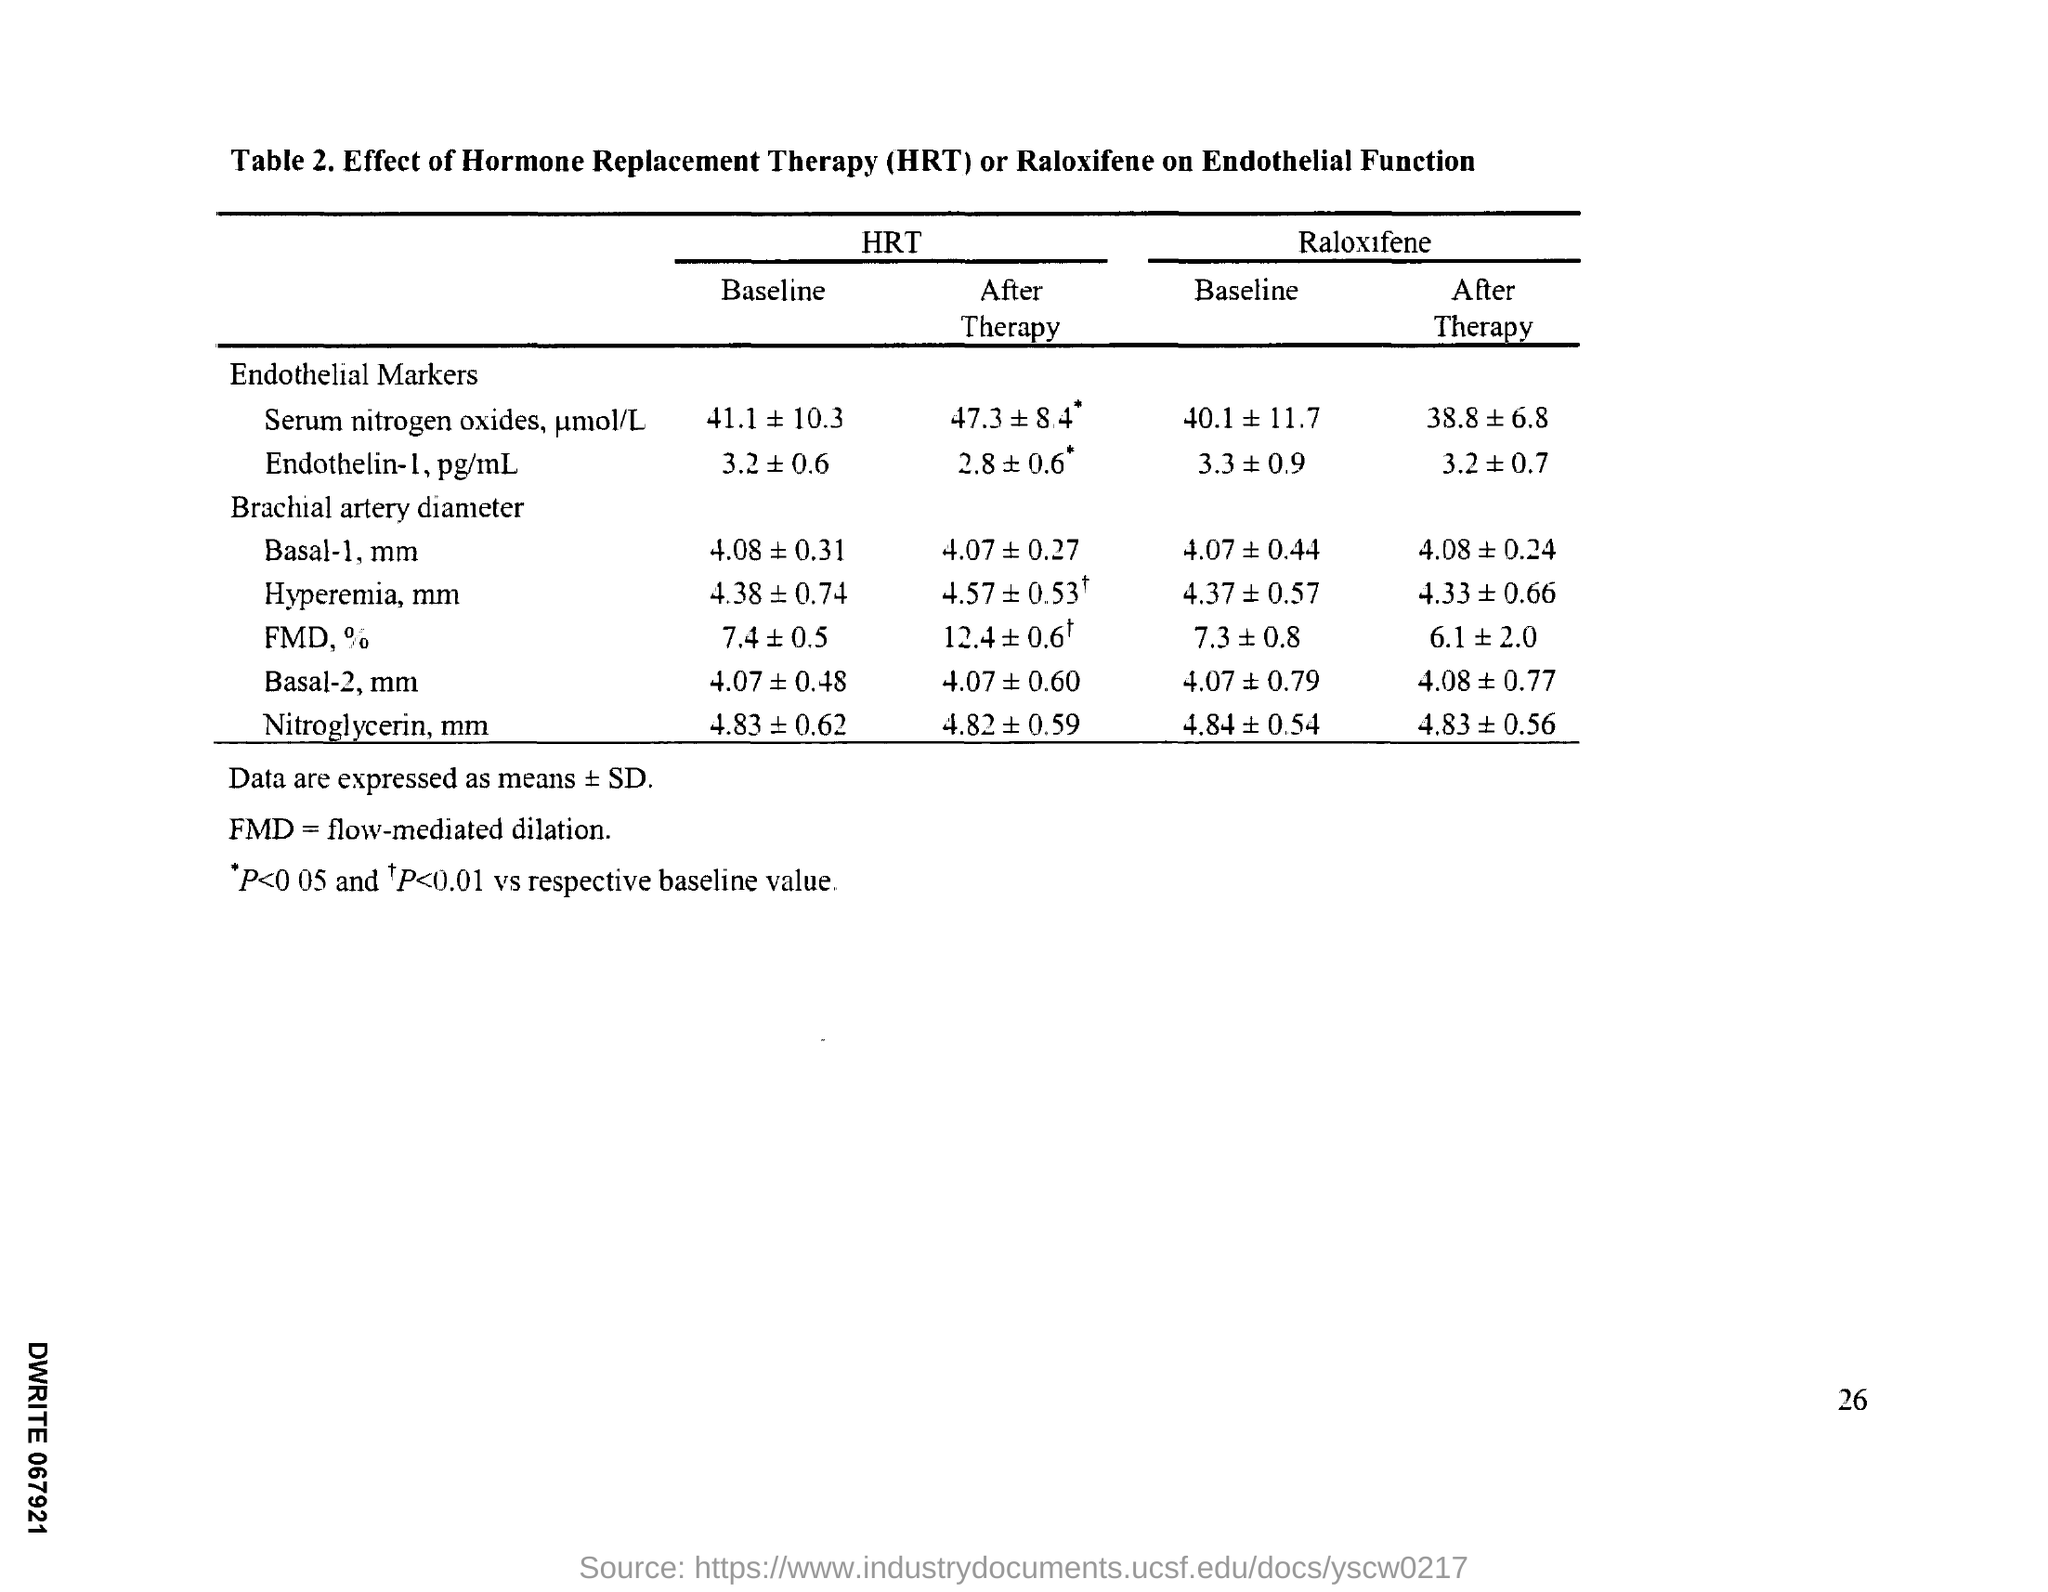Indicate a few pertinent items in this graphic. The page number is 26," the speaker declared. 